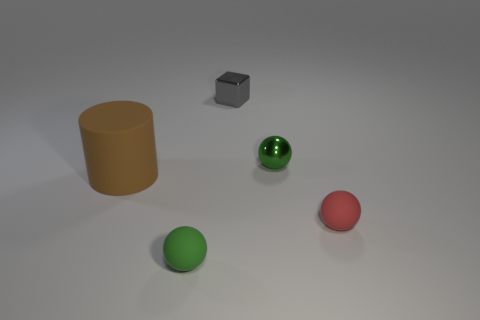The object that is both behind the small red sphere and on the left side of the gray cube has what shape?
Provide a succinct answer. Cylinder. There is a green matte object; are there any large rubber cylinders left of it?
Provide a short and direct response. Yes. Are there any other things that have the same size as the cylinder?
Offer a terse response. No. Does the tiny red thing have the same shape as the green shiny object?
Provide a succinct answer. Yes. How big is the metallic thing behind the sphere behind the brown thing?
Your answer should be compact. Small. There is another matte thing that is the same shape as the small red matte object; what color is it?
Your response must be concise. Green. What number of objects have the same color as the small metallic sphere?
Ensure brevity in your answer.  1. The gray metallic block is what size?
Give a very brief answer. Small. Does the red thing have the same size as the brown rubber thing?
Keep it short and to the point. No. What color is the small thing that is on the left side of the small metallic ball and behind the big brown cylinder?
Keep it short and to the point. Gray. 